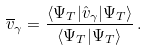Convert formula to latex. <formula><loc_0><loc_0><loc_500><loc_500>\overline { v } _ { \gamma } = \frac { \langle \Psi _ { T } | \hat { v } _ { \gamma } | \Psi _ { T } \rangle } { \langle \Psi _ { T } | \Psi _ { T } \rangle } \, .</formula> 